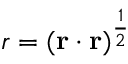Convert formula to latex. <formula><loc_0><loc_0><loc_500><loc_500>r = ( { \mathbf r } \cdot { \mathbf r } ) ^ { \frac { 1 } { 2 } }</formula> 